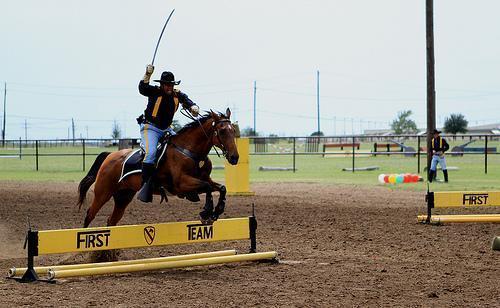How many people are there?
Give a very brief answer. 2. 